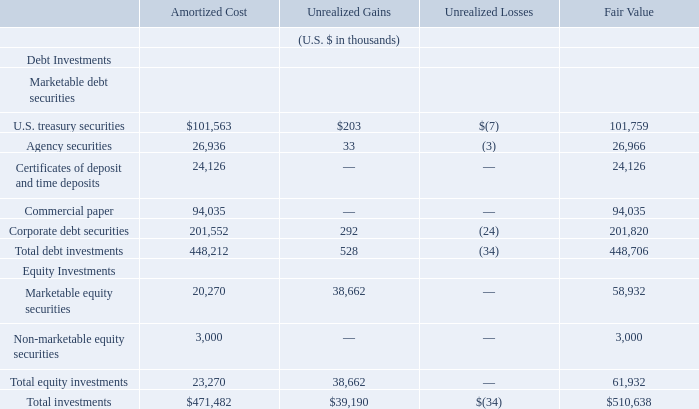Investments
As of June 30, 2019, the Group’s investments consisted of the following:
As of June 30, 2019, the Group had $445.0 million of investments which were classified as short-term investments on the Group’s consolidated statements of financial position. Additionally, the Group had marketable equity securities totaling $58.9 million, non-marketable equity securities totaling $3.0 million, and certificates of deposit and time deposits totaling $3.7 million which were classified as long-term and were included in other non-current assets on the Group’s consolidated statements of financial position.
As of June 30, 2019, what is the value of the Group's marketable equity securities? $58.9 million. As of June 30, 2019, what is the value of the Group's non-marketable equity securities? $3.0 million. As of June 30, 2019, what is the value of the certificates of deposit and time deposits? $3.7 million. What is the difference in the total debt investments and the total equity investments, based on amortized cost?
Answer scale should be: thousand. 448,212-23,270
Answer: 424942. Based on fair value, what is the percentage constitution of U.S. treasury securities among the total debt investments?
Answer scale should be: percent. 101,759/448,706
Answer: 22.68. Based on amortized cost, what is the percentage constitution of total equity investments among the total investments?
Answer scale should be: percent. 23,270/471,482
Answer: 4.94. 